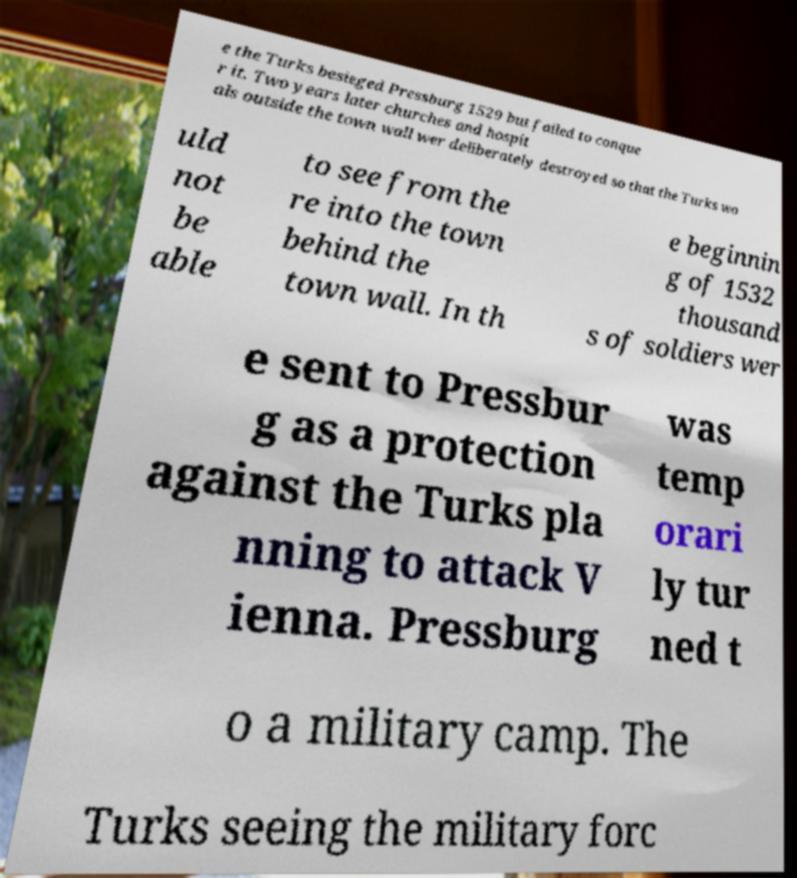For documentation purposes, I need the text within this image transcribed. Could you provide that? e the Turks besieged Pressburg 1529 but failed to conque r it. Two years later churches and hospit als outside the town wall wer deliberately destroyed so that the Turks wo uld not be able to see from the re into the town behind the town wall. In th e beginnin g of 1532 thousand s of soldiers wer e sent to Pressbur g as a protection against the Turks pla nning to attack V ienna. Pressburg was temp orari ly tur ned t o a military camp. The Turks seeing the military forc 